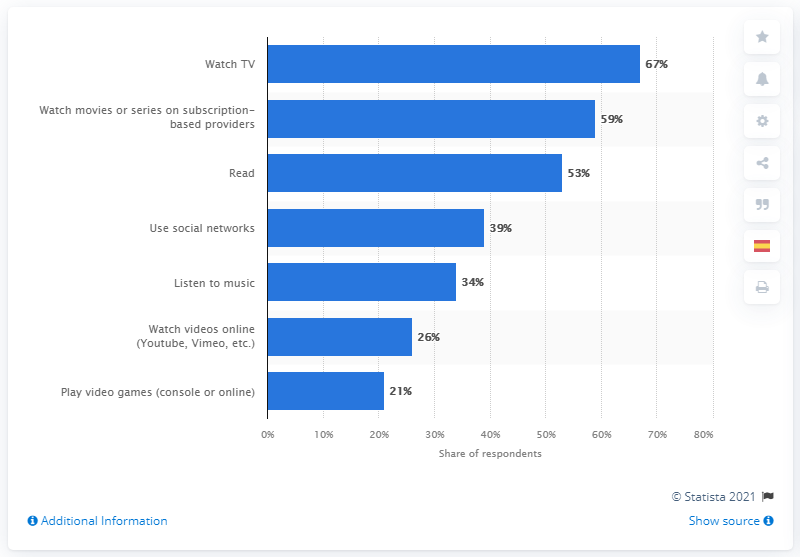Point out several critical features in this image. A majority of respondents, or 59%, reported watching Netflix or Movistar+. A survey conducted in Spain showed that a majority of Spaniards, or 67%, found entertainment in watching TV. 